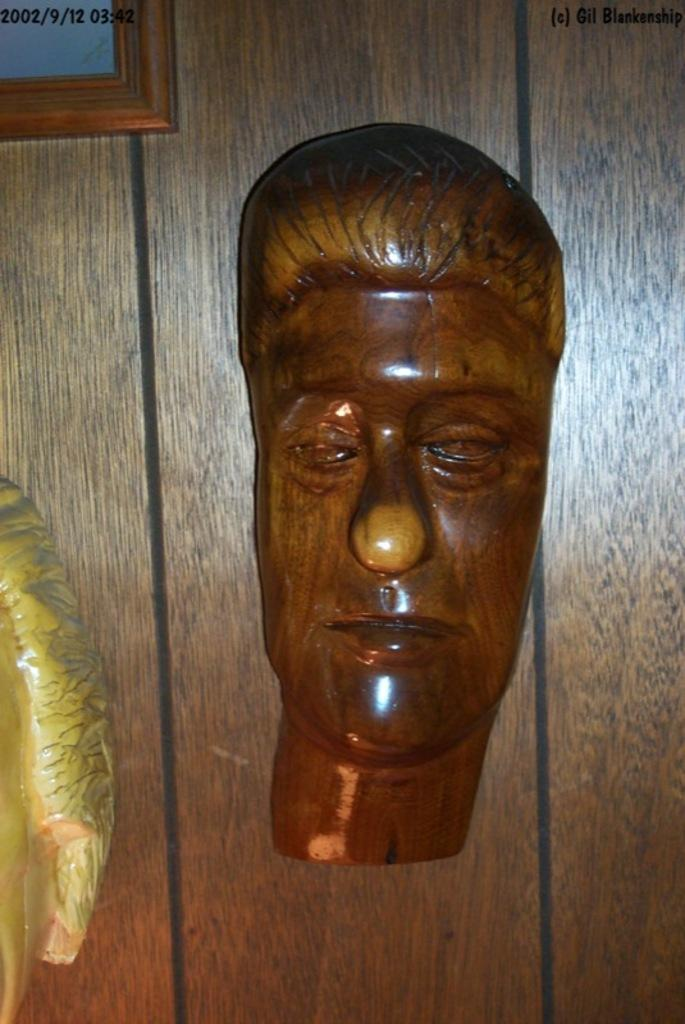What type of mask is shown in the image? There is a wooden face mask in the image. What is the background of the image made of? There are other objects attached to a wooden wall in the image. Can you describe any imperfections or marks on the image? Watermarks are visible on the image. What type of cushion is placed on the sister's bed in the image? There is no sister or bed present in the image; it only features a wooden face mask and a wooden wall with other objects attached. 